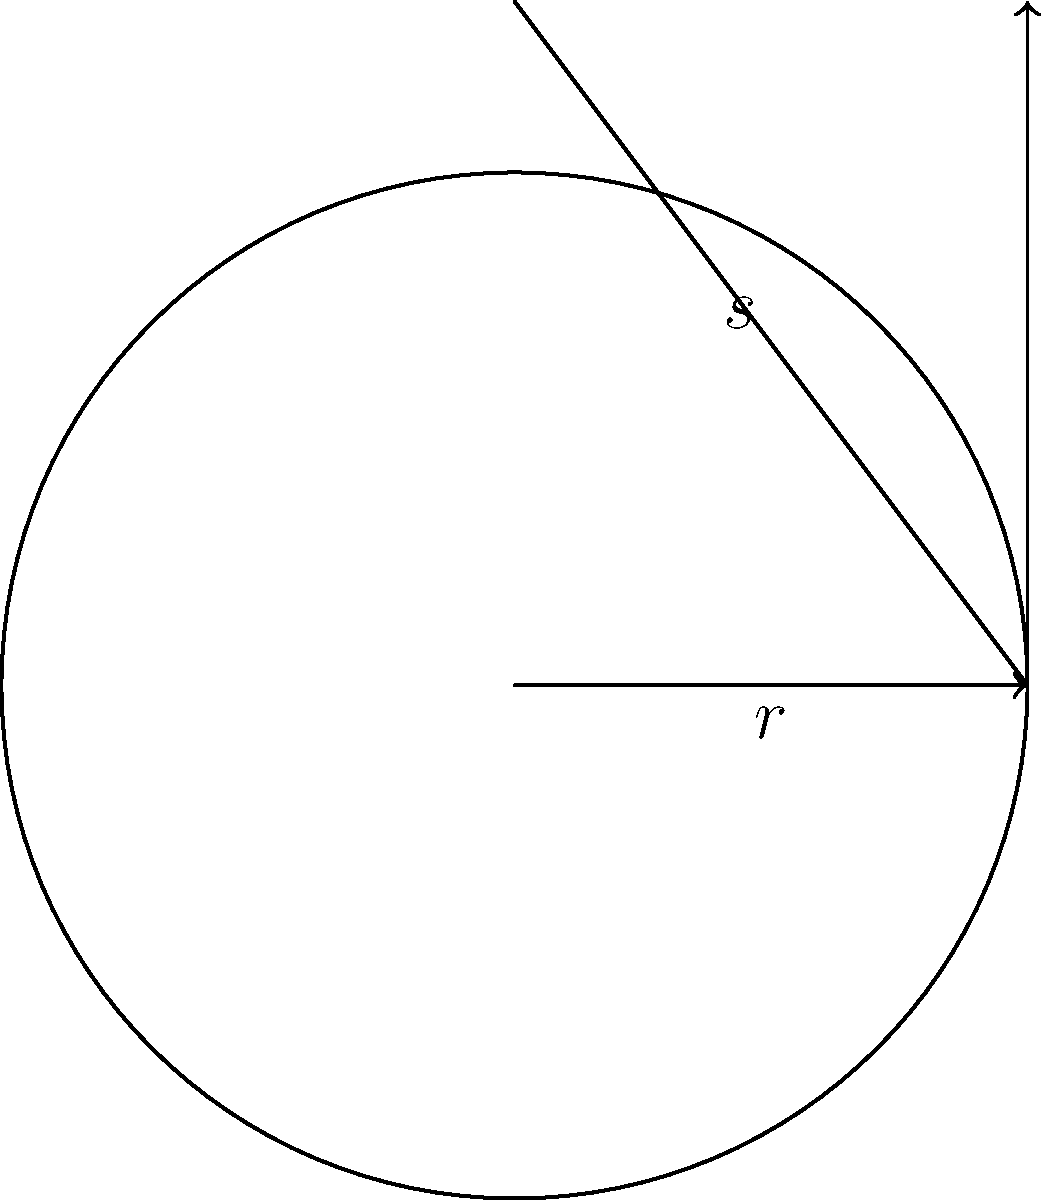In your medieval fantasy world, a master architect is designing a conical tower roof for a noble's keep. The base radius of the roof is 6 meters, and its slant height is 10 meters. Calculate the surface area of the roof, excluding the circular base. Round your answer to the nearest square meter. To calculate the surface area of a conical roof, we need to use the formula for the lateral surface area of a cone:

$$A = \pi rs$$

Where:
$A$ = lateral surface area
$r$ = radius of the base
$s$ = slant height

Given:
$r = 6$ meters
$s = 10$ meters

Step 1: Substitute the values into the formula:
$$A = \pi \cdot 6 \cdot 10$$

Step 2: Calculate:
$$A = 60\pi$$

Step 3: Evaluate and round to the nearest square meter:
$$A \approx 188.5 \approx 189 \text{ square meters}$$

Therefore, the surface area of the conical tower roof is approximately 189 square meters.
Answer: 189 square meters 